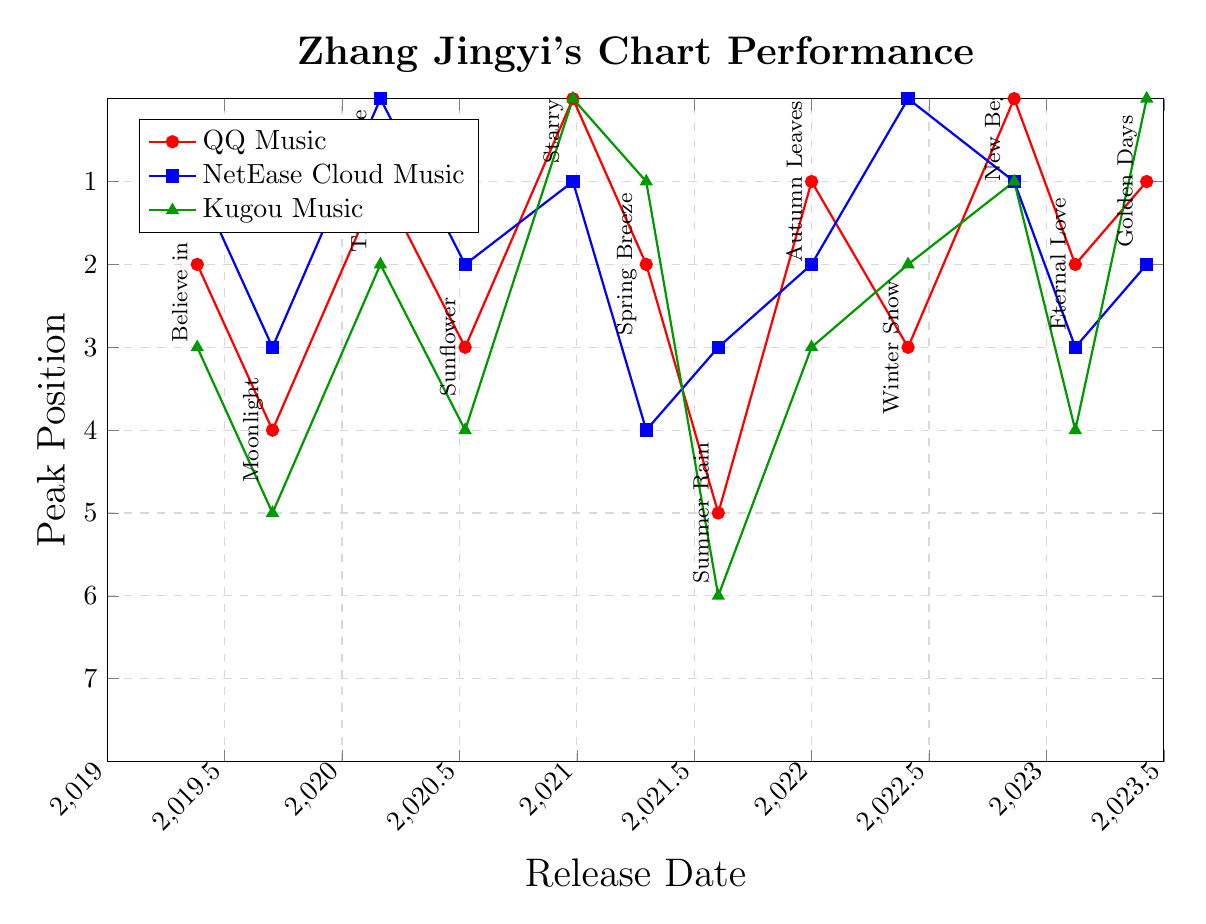Which song had the highest peak position on each chart? To find the song with the highest peak position on each chart, look for the lowest y-value (since the chart axis is inverted) for each line color. For QQ Music, it is "Starry Night" at position 1. For NetEase Cloud Music, it is "Time Capsule" and "Winter Snow" at position 1. For Kugou Music, it is "Starry Night" and "Golden Days" at position 1.
Answer: "Starry Night" on QQ Music, "Time Capsule" and "Winter Snow" on NetEase Cloud Music, "Starry Night" and "Golden Days" on Kugou Music Compare the peak position of "Moonlight" across the three charts. Which chart had the best and worst performance? For "Moonlight", observe its positions on the three lines where its label appears. On QQ Music (red), it is 5th. On NetEase Cloud Music (blue), it is 4th. On Kugou Music (green), it is 6th. The best performance is NetEase Cloud Music, and the worst is Kugou Music.
Answer: Best: NetEase Cloud Music, Worst: Kugou Music What is the average peak position of "New Beginnings" across all charts? Sum the peak positions of "New Beginnings" on QQ Music, NetEase Cloud Music, and Kugou Music, and divide by 3. The positions are 1, 2, and 2 respectively. The sum is 5, so the average is 5 divided by 3.
Answer: Average: 1.67 Which song had the most consistent performance across all charts? Identify the song with the least variation in its peak positions across the three charts by checking labels with the closest y-values. "New Beginnings" has positions 1, 2, and 2, showing the least variation (1).
Answer: "New Beginnings" How did "Golden Days" perform on Kugou Music compared to QQ Music and NetEase Cloud Music? Look at "Golden Days" positions on Kugou, QQ, and NetEase Cloud Music within their respective lines. For Kugou Music (green), it is 1st. For QQ Music (red), it is 2nd. For NetEase Cloud Music (blue), it is 3rd. It performed best on Kugou Music and worst on NetEase Cloud Music.
Answer: Best on Kugou Music, Worst on NetEase Cloud Music Which songs reached the top 3 positions on QQ Music? Locate the red line and find songs with positions 1, 2, and 3. These songs are "Starry Night" (1), "Time Capsule" (2), and "Autumn Leaves" (2), "Golden Days" (2), "Believe in Love" (3), "Spring Breeze" (3), and "New Beginnings" (1).
Answer: "Starry Night", "Time Capsule", "Autumn Leaves", "Golden Days", "Believe in Love", "Spring Breeze", "New Beginnings" What trend do you observe in Zhang Jingyi's singles released in 2022 on NetEase Cloud Music? Analyze the blue line positions for songs released in 2022 ("Autumn Leaves", "Winter Snow", "New Beginnings") to see their y-values. They are 3rd, 1st, and 2nd, respectively, which shows an improving trend then a slight drop.
Answer: Trend: Improving, then slight drop 